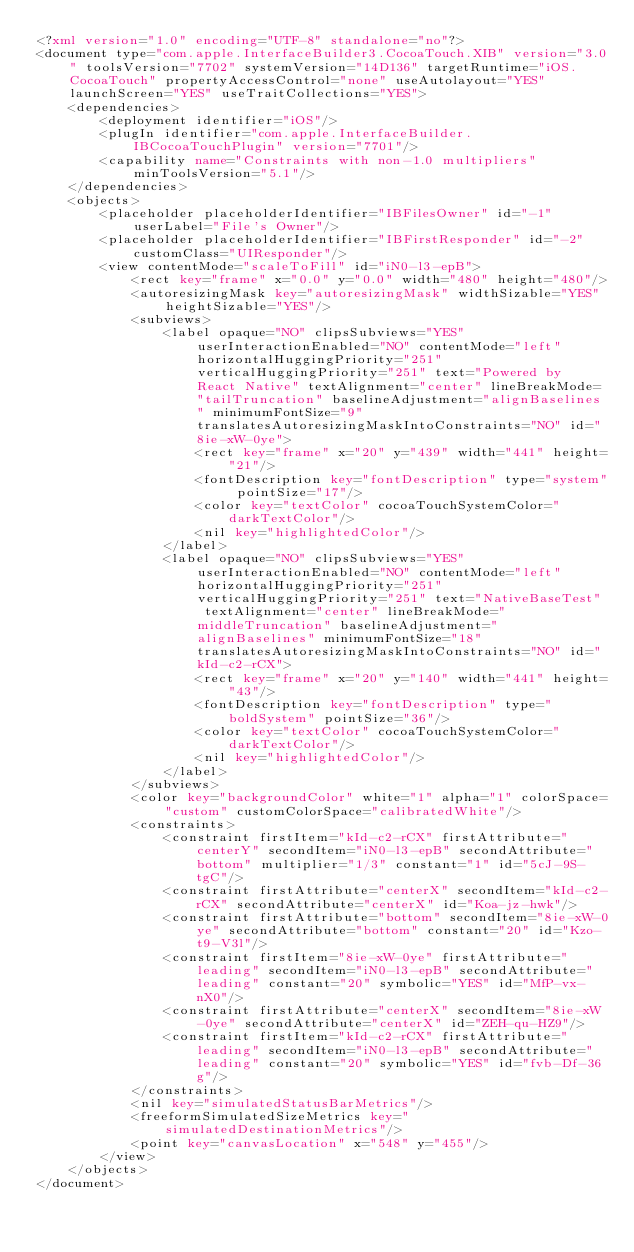<code> <loc_0><loc_0><loc_500><loc_500><_XML_><?xml version="1.0" encoding="UTF-8" standalone="no"?>
<document type="com.apple.InterfaceBuilder3.CocoaTouch.XIB" version="3.0" toolsVersion="7702" systemVersion="14D136" targetRuntime="iOS.CocoaTouch" propertyAccessControl="none" useAutolayout="YES" launchScreen="YES" useTraitCollections="YES">
    <dependencies>
        <deployment identifier="iOS"/>
        <plugIn identifier="com.apple.InterfaceBuilder.IBCocoaTouchPlugin" version="7701"/>
        <capability name="Constraints with non-1.0 multipliers" minToolsVersion="5.1"/>
    </dependencies>
    <objects>
        <placeholder placeholderIdentifier="IBFilesOwner" id="-1" userLabel="File's Owner"/>
        <placeholder placeholderIdentifier="IBFirstResponder" id="-2" customClass="UIResponder"/>
        <view contentMode="scaleToFill" id="iN0-l3-epB">
            <rect key="frame" x="0.0" y="0.0" width="480" height="480"/>
            <autoresizingMask key="autoresizingMask" widthSizable="YES" heightSizable="YES"/>
            <subviews>
                <label opaque="NO" clipsSubviews="YES" userInteractionEnabled="NO" contentMode="left" horizontalHuggingPriority="251" verticalHuggingPriority="251" text="Powered by React Native" textAlignment="center" lineBreakMode="tailTruncation" baselineAdjustment="alignBaselines" minimumFontSize="9" translatesAutoresizingMaskIntoConstraints="NO" id="8ie-xW-0ye">
                    <rect key="frame" x="20" y="439" width="441" height="21"/>
                    <fontDescription key="fontDescription" type="system" pointSize="17"/>
                    <color key="textColor" cocoaTouchSystemColor="darkTextColor"/>
                    <nil key="highlightedColor"/>
                </label>
                <label opaque="NO" clipsSubviews="YES" userInteractionEnabled="NO" contentMode="left" horizontalHuggingPriority="251" verticalHuggingPriority="251" text="NativeBaseTest" textAlignment="center" lineBreakMode="middleTruncation" baselineAdjustment="alignBaselines" minimumFontSize="18" translatesAutoresizingMaskIntoConstraints="NO" id="kId-c2-rCX">
                    <rect key="frame" x="20" y="140" width="441" height="43"/>
                    <fontDescription key="fontDescription" type="boldSystem" pointSize="36"/>
                    <color key="textColor" cocoaTouchSystemColor="darkTextColor"/>
                    <nil key="highlightedColor"/>
                </label>
            </subviews>
            <color key="backgroundColor" white="1" alpha="1" colorSpace="custom" customColorSpace="calibratedWhite"/>
            <constraints>
                <constraint firstItem="kId-c2-rCX" firstAttribute="centerY" secondItem="iN0-l3-epB" secondAttribute="bottom" multiplier="1/3" constant="1" id="5cJ-9S-tgC"/>
                <constraint firstAttribute="centerX" secondItem="kId-c2-rCX" secondAttribute="centerX" id="Koa-jz-hwk"/>
                <constraint firstAttribute="bottom" secondItem="8ie-xW-0ye" secondAttribute="bottom" constant="20" id="Kzo-t9-V3l"/>
                <constraint firstItem="8ie-xW-0ye" firstAttribute="leading" secondItem="iN0-l3-epB" secondAttribute="leading" constant="20" symbolic="YES" id="MfP-vx-nX0"/>
                <constraint firstAttribute="centerX" secondItem="8ie-xW-0ye" secondAttribute="centerX" id="ZEH-qu-HZ9"/>
                <constraint firstItem="kId-c2-rCX" firstAttribute="leading" secondItem="iN0-l3-epB" secondAttribute="leading" constant="20" symbolic="YES" id="fvb-Df-36g"/>
            </constraints>
            <nil key="simulatedStatusBarMetrics"/>
            <freeformSimulatedSizeMetrics key="simulatedDestinationMetrics"/>
            <point key="canvasLocation" x="548" y="455"/>
        </view>
    </objects>
</document>
</code> 